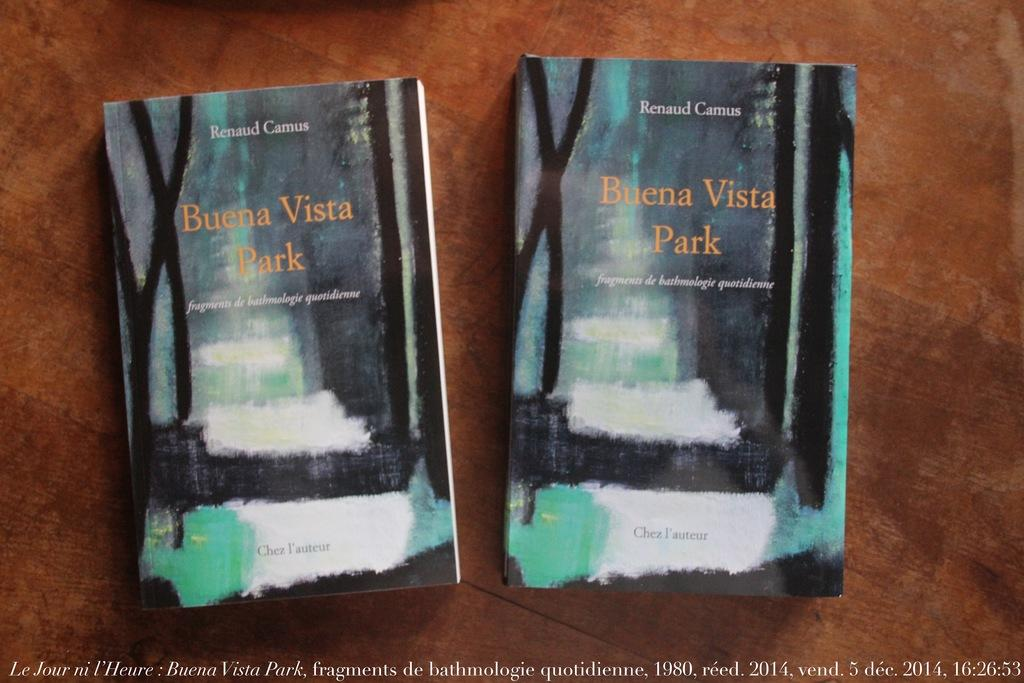Provide a one-sentence caption for the provided image. Two copies of the book Buena Vista park sit next to one another on a table. 